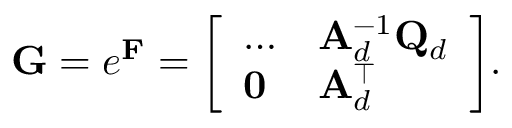<formula> <loc_0><loc_0><loc_500><loc_500>G = e ^ { F } = { \left [ \begin{array} { l l } { \dots } & { A _ { d } ^ { - 1 } Q _ { d } } \\ { 0 } & { A _ { d } ^ { \top } } \end{array} \right ] } .</formula> 